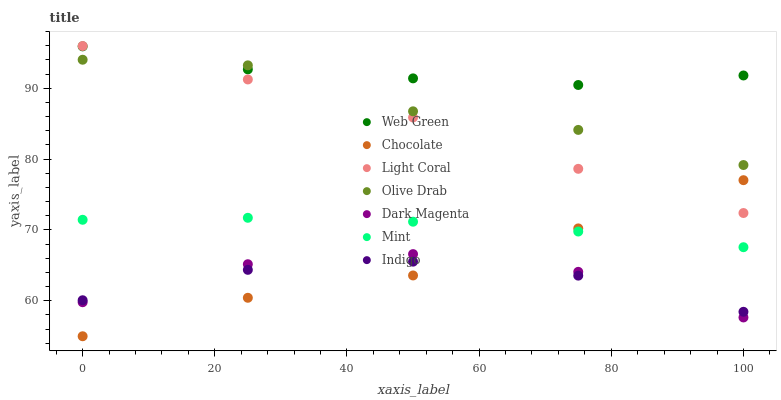Does Indigo have the minimum area under the curve?
Answer yes or no. Yes. Does Web Green have the maximum area under the curve?
Answer yes or no. Yes. Does Dark Magenta have the minimum area under the curve?
Answer yes or no. No. Does Dark Magenta have the maximum area under the curve?
Answer yes or no. No. Is Mint the smoothest?
Answer yes or no. Yes. Is Olive Drab the roughest?
Answer yes or no. Yes. Is Dark Magenta the smoothest?
Answer yes or no. No. Is Dark Magenta the roughest?
Answer yes or no. No. Does Chocolate have the lowest value?
Answer yes or no. Yes. Does Dark Magenta have the lowest value?
Answer yes or no. No. Does Light Coral have the highest value?
Answer yes or no. Yes. Does Dark Magenta have the highest value?
Answer yes or no. No. Is Dark Magenta less than Mint?
Answer yes or no. Yes. Is Web Green greater than Indigo?
Answer yes or no. Yes. Does Olive Drab intersect Light Coral?
Answer yes or no. Yes. Is Olive Drab less than Light Coral?
Answer yes or no. No. Is Olive Drab greater than Light Coral?
Answer yes or no. No. Does Dark Magenta intersect Mint?
Answer yes or no. No. 